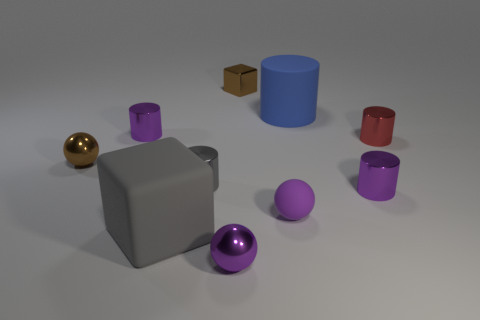Subtract all purple spheres. How many were subtracted if there are1purple spheres left? 1 Subtract all brown cylinders. Subtract all gray blocks. How many cylinders are left? 5 Subtract all blocks. How many objects are left? 8 Add 1 large cyan metallic blocks. How many large cyan metallic blocks exist? 1 Subtract 2 purple cylinders. How many objects are left? 8 Subtract all tiny gray objects. Subtract all yellow shiny things. How many objects are left? 9 Add 7 small gray metallic cylinders. How many small gray metallic cylinders are left? 8 